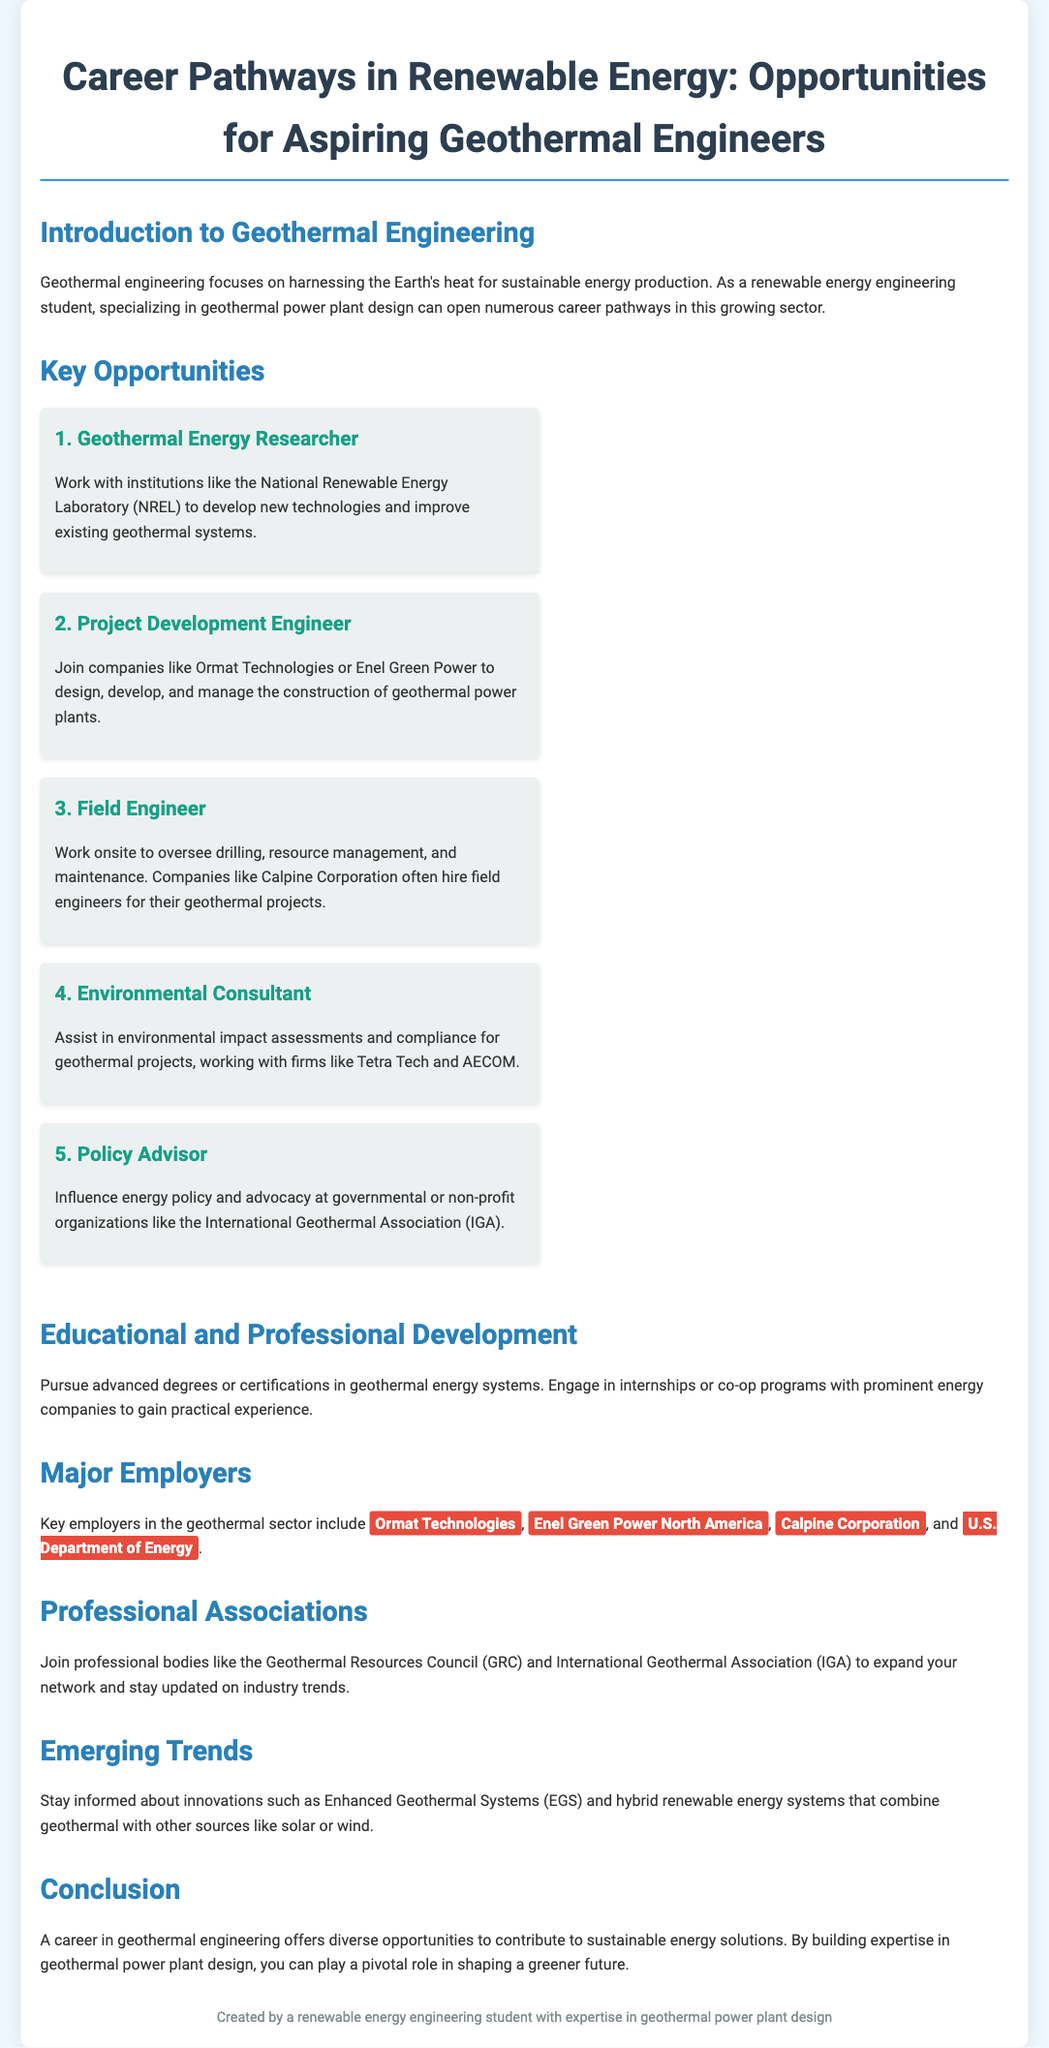What is the title of the flyer? The title of the flyer is displayed prominently at the top of the document, indicating the focus on career pathways in geothermal engineering.
Answer: Career Pathways in Renewable Energy: Opportunities for Aspiring Geothermal Engineers What is one major employer in the geothermal sector? The document lists several key employers in the geothermal sector in the "Major Employers" section.
Answer: Ormat Technologies Name one position a geothermal engineer could pursue. The flyer outlines various roles for aspiring geothermal engineers in the "Key Opportunities" section, specifying potential job titles.
Answer: Project Development Engineer Which organization can you join to expand your network in geothermal engineering? The document mentions professional associations relevant to geothermal engineers, highlighting opportunities for networking and industry updates.
Answer: Geothermal Resources Council What is one emerging trend in geothermal engineering? The "Emerging Trends" section describes innovations that are currently influential in the geothermal sector.
Answer: Enhanced Geothermal Systems (EGS) What should a student do to gain practical experience in geothermal engineering? The flyer suggests pursuing internships or co-op programs to gain real-world experience in the field.
Answer: Engage in internships How many key opportunities are listed for geothermal engineers? The document explicitly enumerates the career paths available to aspiring geothermal engineers within the "Key Opportunities" section.
Answer: Five What is the focus of geothermal engineering? The introduction of the document outlines the primary objective of this engineering field.
Answer: Harnessing the Earth's heat Which company is known for geothermal project management? The document mentions companies involved in geothermal project development in its "Key Opportunities" section.
Answer: Enel Green Power 